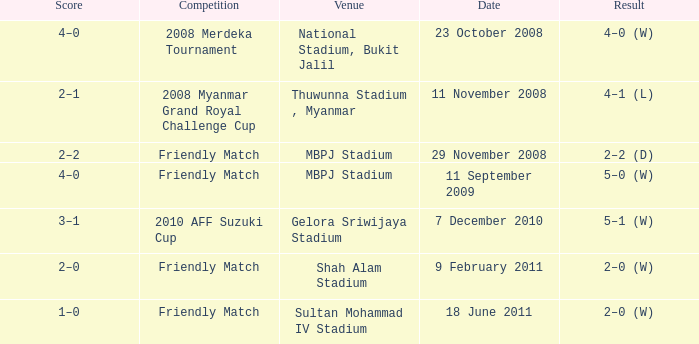What is the Venue of the Competition with a Result of 2–2 (d)? MBPJ Stadium. 